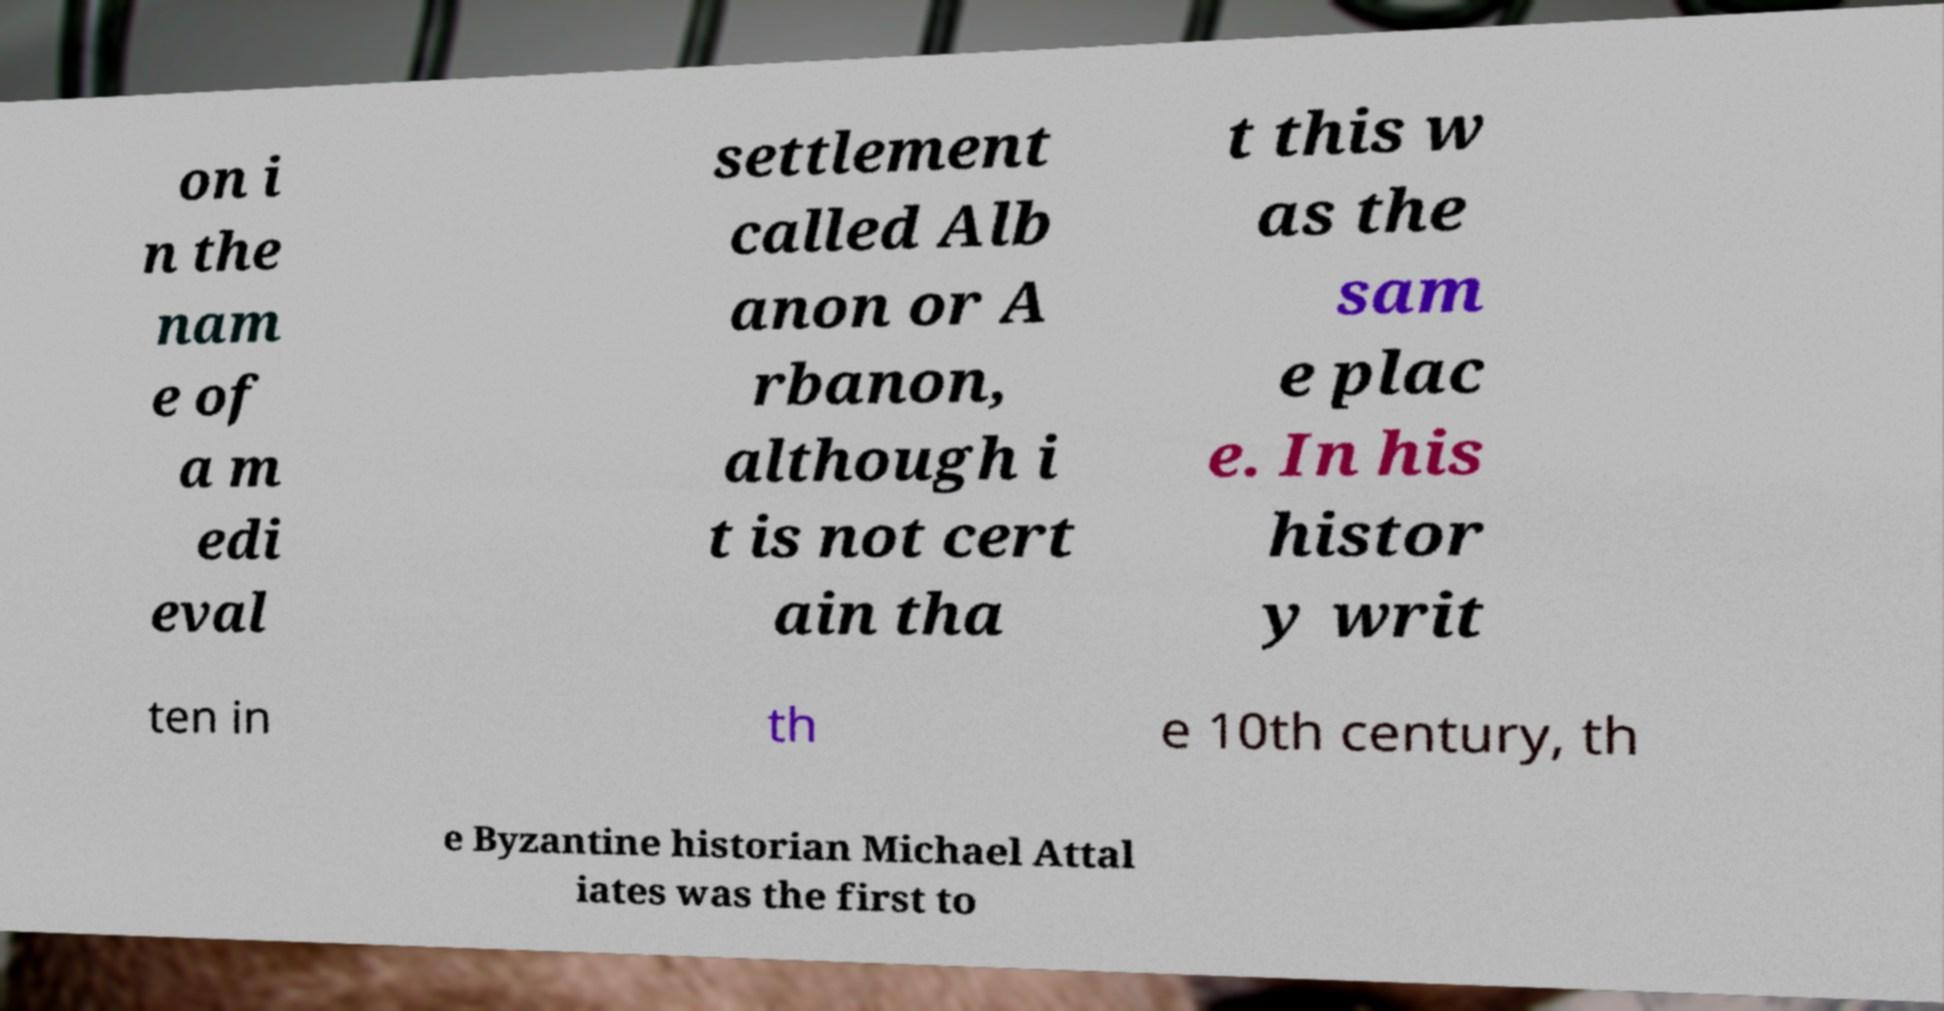Please read and relay the text visible in this image. What does it say? on i n the nam e of a m edi eval settlement called Alb anon or A rbanon, although i t is not cert ain tha t this w as the sam e plac e. In his histor y writ ten in th e 10th century, th e Byzantine historian Michael Attal iates was the first to 